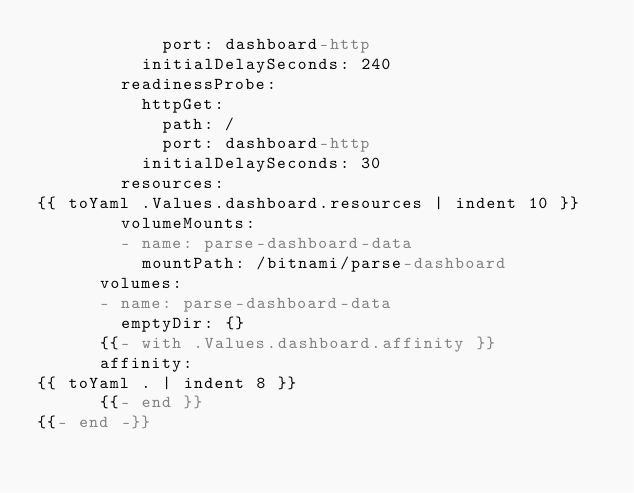<code> <loc_0><loc_0><loc_500><loc_500><_YAML_>            port: dashboard-http
          initialDelaySeconds: 240
        readinessProbe:
          httpGet:
            path: /
            port: dashboard-http
          initialDelaySeconds: 30
        resources:
{{ toYaml .Values.dashboard.resources | indent 10 }}
        volumeMounts:
        - name: parse-dashboard-data
          mountPath: /bitnami/parse-dashboard
      volumes:
      - name: parse-dashboard-data
        emptyDir: {}
      {{- with .Values.dashboard.affinity }}
      affinity:
{{ toYaml . | indent 8 }}
      {{- end }}
{{- end -}}
</code> 